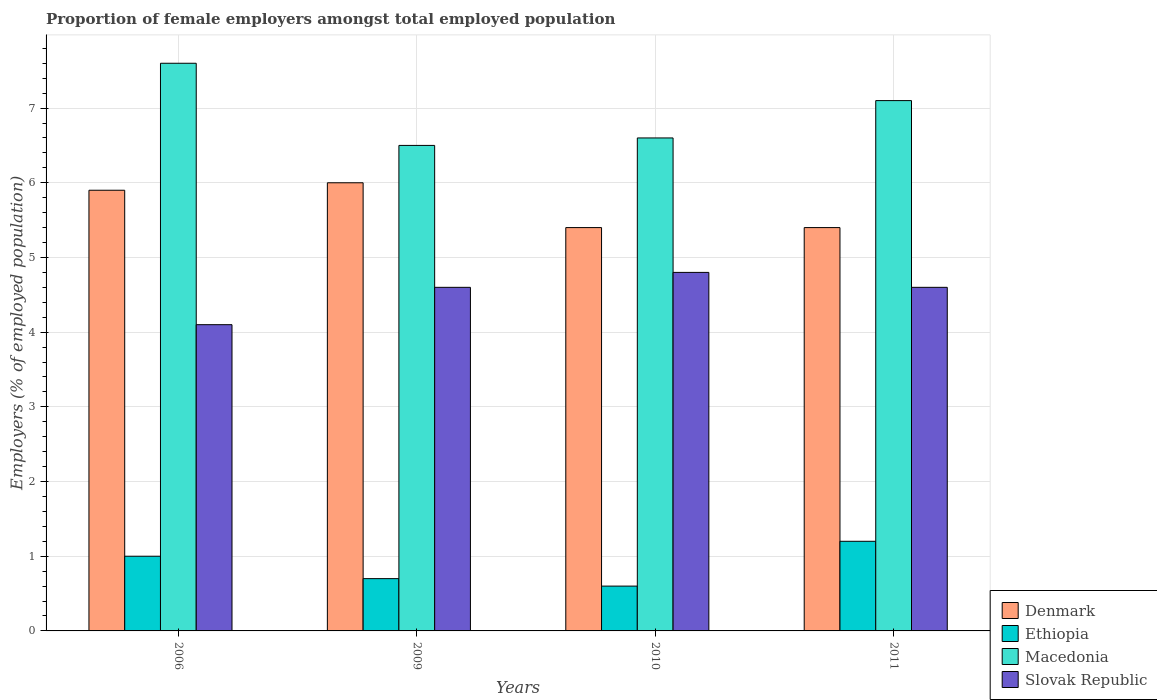Are the number of bars on each tick of the X-axis equal?
Provide a short and direct response. Yes. How many bars are there on the 2nd tick from the left?
Give a very brief answer. 4. How many bars are there on the 3rd tick from the right?
Give a very brief answer. 4. What is the label of the 4th group of bars from the left?
Your response must be concise. 2011. In how many cases, is the number of bars for a given year not equal to the number of legend labels?
Your response must be concise. 0. What is the proportion of female employers in Macedonia in 2009?
Ensure brevity in your answer.  6.5. Across all years, what is the maximum proportion of female employers in Slovak Republic?
Keep it short and to the point. 4.8. Across all years, what is the minimum proportion of female employers in Ethiopia?
Your answer should be very brief. 0.6. In which year was the proportion of female employers in Macedonia maximum?
Provide a succinct answer. 2006. In which year was the proportion of female employers in Ethiopia minimum?
Ensure brevity in your answer.  2010. What is the total proportion of female employers in Macedonia in the graph?
Provide a short and direct response. 27.8. What is the difference between the proportion of female employers in Slovak Republic in 2006 and that in 2011?
Your response must be concise. -0.5. What is the difference between the proportion of female employers in Ethiopia in 2010 and the proportion of female employers in Denmark in 2009?
Provide a succinct answer. -5.4. What is the average proportion of female employers in Slovak Republic per year?
Your response must be concise. 4.52. In the year 2010, what is the difference between the proportion of female employers in Denmark and proportion of female employers in Ethiopia?
Keep it short and to the point. 4.8. What is the ratio of the proportion of female employers in Denmark in 2009 to that in 2010?
Ensure brevity in your answer.  1.11. Is the proportion of female employers in Ethiopia in 2009 less than that in 2011?
Provide a short and direct response. Yes. What is the difference between the highest and the second highest proportion of female employers in Ethiopia?
Keep it short and to the point. 0.2. What is the difference between the highest and the lowest proportion of female employers in Macedonia?
Your answer should be compact. 1.1. In how many years, is the proportion of female employers in Denmark greater than the average proportion of female employers in Denmark taken over all years?
Provide a succinct answer. 2. Is it the case that in every year, the sum of the proportion of female employers in Macedonia and proportion of female employers in Denmark is greater than the sum of proportion of female employers in Slovak Republic and proportion of female employers in Ethiopia?
Make the answer very short. Yes. What does the 3rd bar from the left in 2011 represents?
Your answer should be very brief. Macedonia. What does the 3rd bar from the right in 2011 represents?
Your response must be concise. Ethiopia. How many years are there in the graph?
Ensure brevity in your answer.  4. What is the difference between two consecutive major ticks on the Y-axis?
Make the answer very short. 1. Where does the legend appear in the graph?
Your answer should be very brief. Bottom right. What is the title of the graph?
Your response must be concise. Proportion of female employers amongst total employed population. Does "Mozambique" appear as one of the legend labels in the graph?
Offer a very short reply. No. What is the label or title of the X-axis?
Ensure brevity in your answer.  Years. What is the label or title of the Y-axis?
Provide a succinct answer. Employers (% of employed population). What is the Employers (% of employed population) in Denmark in 2006?
Offer a terse response. 5.9. What is the Employers (% of employed population) of Ethiopia in 2006?
Offer a very short reply. 1. What is the Employers (% of employed population) in Macedonia in 2006?
Your response must be concise. 7.6. What is the Employers (% of employed population) in Slovak Republic in 2006?
Offer a terse response. 4.1. What is the Employers (% of employed population) of Ethiopia in 2009?
Offer a terse response. 0.7. What is the Employers (% of employed population) in Macedonia in 2009?
Ensure brevity in your answer.  6.5. What is the Employers (% of employed population) in Slovak Republic in 2009?
Your answer should be very brief. 4.6. What is the Employers (% of employed population) in Denmark in 2010?
Your response must be concise. 5.4. What is the Employers (% of employed population) of Ethiopia in 2010?
Offer a terse response. 0.6. What is the Employers (% of employed population) in Macedonia in 2010?
Provide a succinct answer. 6.6. What is the Employers (% of employed population) of Slovak Republic in 2010?
Ensure brevity in your answer.  4.8. What is the Employers (% of employed population) of Denmark in 2011?
Provide a succinct answer. 5.4. What is the Employers (% of employed population) in Ethiopia in 2011?
Provide a short and direct response. 1.2. What is the Employers (% of employed population) of Macedonia in 2011?
Keep it short and to the point. 7.1. What is the Employers (% of employed population) in Slovak Republic in 2011?
Offer a terse response. 4.6. Across all years, what is the maximum Employers (% of employed population) of Ethiopia?
Offer a terse response. 1.2. Across all years, what is the maximum Employers (% of employed population) in Macedonia?
Your answer should be compact. 7.6. Across all years, what is the maximum Employers (% of employed population) in Slovak Republic?
Offer a terse response. 4.8. Across all years, what is the minimum Employers (% of employed population) of Denmark?
Offer a very short reply. 5.4. Across all years, what is the minimum Employers (% of employed population) of Ethiopia?
Offer a terse response. 0.6. Across all years, what is the minimum Employers (% of employed population) in Macedonia?
Give a very brief answer. 6.5. Across all years, what is the minimum Employers (% of employed population) in Slovak Republic?
Your answer should be compact. 4.1. What is the total Employers (% of employed population) in Denmark in the graph?
Give a very brief answer. 22.7. What is the total Employers (% of employed population) in Macedonia in the graph?
Give a very brief answer. 27.8. What is the total Employers (% of employed population) of Slovak Republic in the graph?
Offer a very short reply. 18.1. What is the difference between the Employers (% of employed population) of Ethiopia in 2006 and that in 2009?
Your answer should be compact. 0.3. What is the difference between the Employers (% of employed population) in Macedonia in 2006 and that in 2009?
Offer a terse response. 1.1. What is the difference between the Employers (% of employed population) of Slovak Republic in 2006 and that in 2009?
Your response must be concise. -0.5. What is the difference between the Employers (% of employed population) in Ethiopia in 2006 and that in 2010?
Make the answer very short. 0.4. What is the difference between the Employers (% of employed population) of Slovak Republic in 2006 and that in 2010?
Give a very brief answer. -0.7. What is the difference between the Employers (% of employed population) of Slovak Republic in 2006 and that in 2011?
Your response must be concise. -0.5. What is the difference between the Employers (% of employed population) in Denmark in 2009 and that in 2010?
Keep it short and to the point. 0.6. What is the difference between the Employers (% of employed population) in Slovak Republic in 2009 and that in 2010?
Offer a very short reply. -0.2. What is the difference between the Employers (% of employed population) of Macedonia in 2009 and that in 2011?
Offer a very short reply. -0.6. What is the difference between the Employers (% of employed population) in Slovak Republic in 2009 and that in 2011?
Provide a succinct answer. 0. What is the difference between the Employers (% of employed population) of Denmark in 2010 and that in 2011?
Your answer should be compact. 0. What is the difference between the Employers (% of employed population) of Ethiopia in 2010 and that in 2011?
Your answer should be very brief. -0.6. What is the difference between the Employers (% of employed population) of Slovak Republic in 2010 and that in 2011?
Your answer should be compact. 0.2. What is the difference between the Employers (% of employed population) in Denmark in 2006 and the Employers (% of employed population) in Slovak Republic in 2009?
Offer a terse response. 1.3. What is the difference between the Employers (% of employed population) of Ethiopia in 2006 and the Employers (% of employed population) of Macedonia in 2009?
Your answer should be very brief. -5.5. What is the difference between the Employers (% of employed population) of Denmark in 2006 and the Employers (% of employed population) of Ethiopia in 2010?
Offer a terse response. 5.3. What is the difference between the Employers (% of employed population) in Denmark in 2006 and the Employers (% of employed population) in Macedonia in 2010?
Your answer should be very brief. -0.7. What is the difference between the Employers (% of employed population) in Ethiopia in 2006 and the Employers (% of employed population) in Macedonia in 2010?
Offer a terse response. -5.6. What is the difference between the Employers (% of employed population) of Ethiopia in 2006 and the Employers (% of employed population) of Slovak Republic in 2010?
Offer a very short reply. -3.8. What is the difference between the Employers (% of employed population) of Macedonia in 2006 and the Employers (% of employed population) of Slovak Republic in 2010?
Give a very brief answer. 2.8. What is the difference between the Employers (% of employed population) in Denmark in 2006 and the Employers (% of employed population) in Slovak Republic in 2011?
Your answer should be compact. 1.3. What is the difference between the Employers (% of employed population) of Ethiopia in 2006 and the Employers (% of employed population) of Macedonia in 2011?
Provide a succinct answer. -6.1. What is the difference between the Employers (% of employed population) in Ethiopia in 2006 and the Employers (% of employed population) in Slovak Republic in 2011?
Provide a succinct answer. -3.6. What is the difference between the Employers (% of employed population) in Macedonia in 2006 and the Employers (% of employed population) in Slovak Republic in 2011?
Provide a succinct answer. 3. What is the difference between the Employers (% of employed population) of Denmark in 2009 and the Employers (% of employed population) of Macedonia in 2010?
Provide a succinct answer. -0.6. What is the difference between the Employers (% of employed population) in Ethiopia in 2009 and the Employers (% of employed population) in Macedonia in 2010?
Your answer should be very brief. -5.9. What is the difference between the Employers (% of employed population) in Ethiopia in 2009 and the Employers (% of employed population) in Slovak Republic in 2010?
Offer a very short reply. -4.1. What is the difference between the Employers (% of employed population) in Macedonia in 2009 and the Employers (% of employed population) in Slovak Republic in 2010?
Your response must be concise. 1.7. What is the difference between the Employers (% of employed population) of Denmark in 2009 and the Employers (% of employed population) of Ethiopia in 2011?
Keep it short and to the point. 4.8. What is the difference between the Employers (% of employed population) of Ethiopia in 2009 and the Employers (% of employed population) of Macedonia in 2011?
Provide a short and direct response. -6.4. What is the difference between the Employers (% of employed population) in Denmark in 2010 and the Employers (% of employed population) in Ethiopia in 2011?
Offer a terse response. 4.2. What is the difference between the Employers (% of employed population) in Denmark in 2010 and the Employers (% of employed population) in Macedonia in 2011?
Your response must be concise. -1.7. What is the difference between the Employers (% of employed population) in Denmark in 2010 and the Employers (% of employed population) in Slovak Republic in 2011?
Offer a terse response. 0.8. What is the difference between the Employers (% of employed population) in Ethiopia in 2010 and the Employers (% of employed population) in Macedonia in 2011?
Provide a succinct answer. -6.5. What is the difference between the Employers (% of employed population) in Macedonia in 2010 and the Employers (% of employed population) in Slovak Republic in 2011?
Offer a very short reply. 2. What is the average Employers (% of employed population) of Denmark per year?
Your answer should be compact. 5.67. What is the average Employers (% of employed population) of Ethiopia per year?
Provide a succinct answer. 0.88. What is the average Employers (% of employed population) of Macedonia per year?
Your response must be concise. 6.95. What is the average Employers (% of employed population) of Slovak Republic per year?
Your answer should be compact. 4.53. In the year 2006, what is the difference between the Employers (% of employed population) of Denmark and Employers (% of employed population) of Macedonia?
Ensure brevity in your answer.  -1.7. In the year 2006, what is the difference between the Employers (% of employed population) in Denmark and Employers (% of employed population) in Slovak Republic?
Give a very brief answer. 1.8. In the year 2006, what is the difference between the Employers (% of employed population) of Ethiopia and Employers (% of employed population) of Macedonia?
Make the answer very short. -6.6. In the year 2006, what is the difference between the Employers (% of employed population) of Ethiopia and Employers (% of employed population) of Slovak Republic?
Your response must be concise. -3.1. In the year 2006, what is the difference between the Employers (% of employed population) of Macedonia and Employers (% of employed population) of Slovak Republic?
Give a very brief answer. 3.5. In the year 2009, what is the difference between the Employers (% of employed population) of Denmark and Employers (% of employed population) of Ethiopia?
Offer a terse response. 5.3. In the year 2009, what is the difference between the Employers (% of employed population) in Denmark and Employers (% of employed population) in Slovak Republic?
Provide a short and direct response. 1.4. In the year 2009, what is the difference between the Employers (% of employed population) in Ethiopia and Employers (% of employed population) in Slovak Republic?
Give a very brief answer. -3.9. In the year 2010, what is the difference between the Employers (% of employed population) in Ethiopia and Employers (% of employed population) in Slovak Republic?
Offer a very short reply. -4.2. In the year 2010, what is the difference between the Employers (% of employed population) of Macedonia and Employers (% of employed population) of Slovak Republic?
Provide a short and direct response. 1.8. In the year 2011, what is the difference between the Employers (% of employed population) of Denmark and Employers (% of employed population) of Ethiopia?
Make the answer very short. 4.2. In the year 2011, what is the difference between the Employers (% of employed population) of Ethiopia and Employers (% of employed population) of Macedonia?
Your response must be concise. -5.9. In the year 2011, what is the difference between the Employers (% of employed population) in Macedonia and Employers (% of employed population) in Slovak Republic?
Offer a very short reply. 2.5. What is the ratio of the Employers (% of employed population) in Denmark in 2006 to that in 2009?
Provide a short and direct response. 0.98. What is the ratio of the Employers (% of employed population) in Ethiopia in 2006 to that in 2009?
Give a very brief answer. 1.43. What is the ratio of the Employers (% of employed population) of Macedonia in 2006 to that in 2009?
Your response must be concise. 1.17. What is the ratio of the Employers (% of employed population) in Slovak Republic in 2006 to that in 2009?
Your response must be concise. 0.89. What is the ratio of the Employers (% of employed population) of Denmark in 2006 to that in 2010?
Provide a short and direct response. 1.09. What is the ratio of the Employers (% of employed population) in Macedonia in 2006 to that in 2010?
Your answer should be very brief. 1.15. What is the ratio of the Employers (% of employed population) of Slovak Republic in 2006 to that in 2010?
Make the answer very short. 0.85. What is the ratio of the Employers (% of employed population) of Denmark in 2006 to that in 2011?
Provide a succinct answer. 1.09. What is the ratio of the Employers (% of employed population) in Macedonia in 2006 to that in 2011?
Make the answer very short. 1.07. What is the ratio of the Employers (% of employed population) in Slovak Republic in 2006 to that in 2011?
Make the answer very short. 0.89. What is the ratio of the Employers (% of employed population) in Macedonia in 2009 to that in 2010?
Your response must be concise. 0.98. What is the ratio of the Employers (% of employed population) of Denmark in 2009 to that in 2011?
Give a very brief answer. 1.11. What is the ratio of the Employers (% of employed population) of Ethiopia in 2009 to that in 2011?
Provide a succinct answer. 0.58. What is the ratio of the Employers (% of employed population) of Macedonia in 2009 to that in 2011?
Provide a succinct answer. 0.92. What is the ratio of the Employers (% of employed population) of Slovak Republic in 2009 to that in 2011?
Your answer should be very brief. 1. What is the ratio of the Employers (% of employed population) of Denmark in 2010 to that in 2011?
Provide a succinct answer. 1. What is the ratio of the Employers (% of employed population) of Macedonia in 2010 to that in 2011?
Provide a succinct answer. 0.93. What is the ratio of the Employers (% of employed population) in Slovak Republic in 2010 to that in 2011?
Your answer should be compact. 1.04. What is the difference between the highest and the second highest Employers (% of employed population) of Ethiopia?
Your response must be concise. 0.2. What is the difference between the highest and the second highest Employers (% of employed population) in Slovak Republic?
Provide a short and direct response. 0.2. What is the difference between the highest and the lowest Employers (% of employed population) in Ethiopia?
Make the answer very short. 0.6. What is the difference between the highest and the lowest Employers (% of employed population) of Macedonia?
Offer a very short reply. 1.1. 